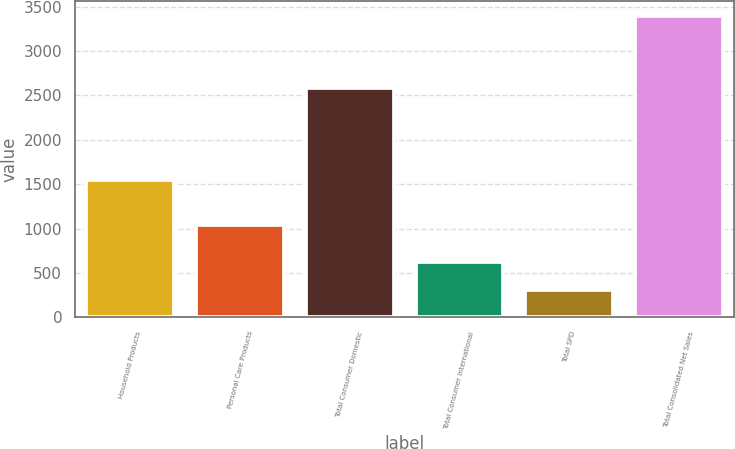Convert chart to OTSL. <chart><loc_0><loc_0><loc_500><loc_500><bar_chart><fcel>Household Products<fcel>Personal Care Products<fcel>Total Consumer Domestic<fcel>Total Consumer International<fcel>Total SPD<fcel>Total Consolidated Net Sales<nl><fcel>1544.3<fcel>1037.3<fcel>2581.6<fcel>620.46<fcel>312.2<fcel>3394.8<nl></chart> 